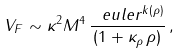<formula> <loc_0><loc_0><loc_500><loc_500>V _ { F } \sim \kappa ^ { 2 } M ^ { 4 } \, \frac { \ e u l e r ^ { k ( \rho ) } } { ( 1 + \kappa _ { \rho } \, \rho ) } \, ,</formula> 